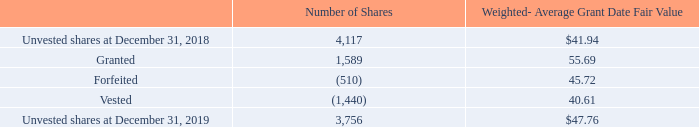Restricted Stock Units
RSU activity is summarized as follows (shares in thousands):
The weighted-average grant date fair value of RSUs granted during the years ended December 31, 2019, 2018, and 2017 was $55.69, $46.17, and $37.99, respectively. The total fair value of RSUs vested as of the vesting dates during the years ended December 31, 2019, 2018, and 2017 was $58.4 million, $49.9 million, and $37.2 million, respectively.
Unrecognized compensation expense related to unvested RSUs was $127.2 million at December 31, 2019, which is expected to be recognized over a weighted-average period of 2.6 years.
What was the weighted average grant date fair value of RSUs during 2019? $55.69. What was the number of granted shares?
Answer scale should be: thousand. 1,589. What was the unrecognized compensation expense related to unvested RSUs in 2019? $127.2 million. What is the change in number of unvested shares between 2018 and 2019?
Answer scale should be: thousand. (3,756-4,117)
Answer: -361. What is the difference in weighted-average grant date fair value between granted and forfeited shares? (55.69-45.72)
Answer: 9.97. What is the difference in weighted-average grant date fair value for unvested shares in 2018 and vested shares? (41.94-40.61)
Answer: 1.33. 